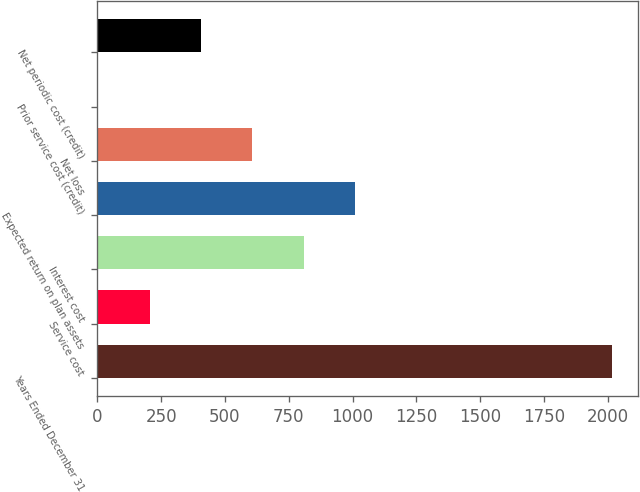Convert chart to OTSL. <chart><loc_0><loc_0><loc_500><loc_500><bar_chart><fcel>Years Ended December 31<fcel>Service cost<fcel>Interest cost<fcel>Expected return on plan assets<fcel>Net loss<fcel>Prior service cost (credit)<fcel>Net periodic cost (credit)<nl><fcel>2016<fcel>205.2<fcel>808.8<fcel>1010<fcel>607.6<fcel>4<fcel>406.4<nl></chart> 